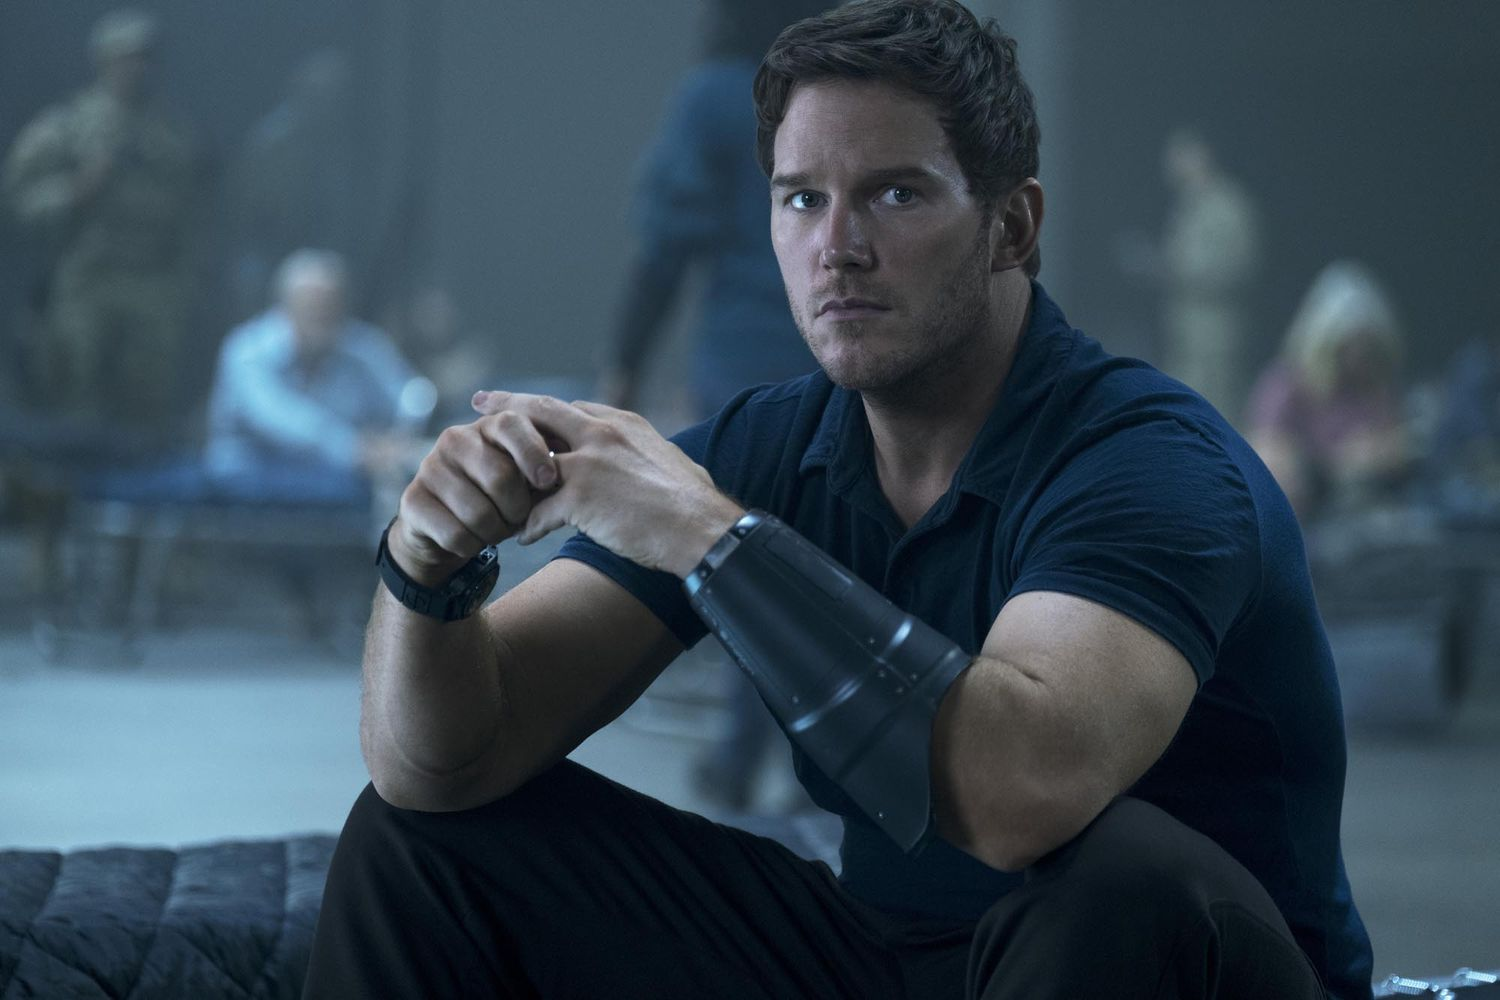If this scene is part of a realistic scenario, what might be going on? In a realistic scenario, this could be a scene from a military operation or crisis response event. The character could be a leader or special operative, preparing to execute an urgent plan. The device might be a communication tool or a piece of equipment required for the task ahead, and the people in the background are his team members or other operatives getting ready for action. What is the significance of the background people? The people in the background, though blurred, are integral to the scene. Their presence suggests teamwork and the scale of the operation. They might be providing support, handling other responsibilities, or simply reassessing the situation, contributing to the overall tension and importance of the moment. 